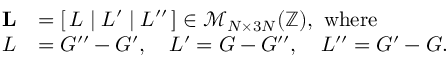<formula> <loc_0><loc_0><loc_500><loc_500>\begin{array} { r l } { L } & { = [ \, L \, | \, L ^ { \prime } \, | \, L ^ { \prime \prime } \, ] \in \mathcal { M } _ { N \times 3 N } ( \mathbb { Z } ) , \ w h e r e } \\ { L } & { = G ^ { \prime \prime } - G ^ { \prime } , \quad L ^ { \prime } = G - G ^ { \prime \prime } , \quad L ^ { \prime \prime } = G ^ { \prime } - G . } \end{array}</formula> 